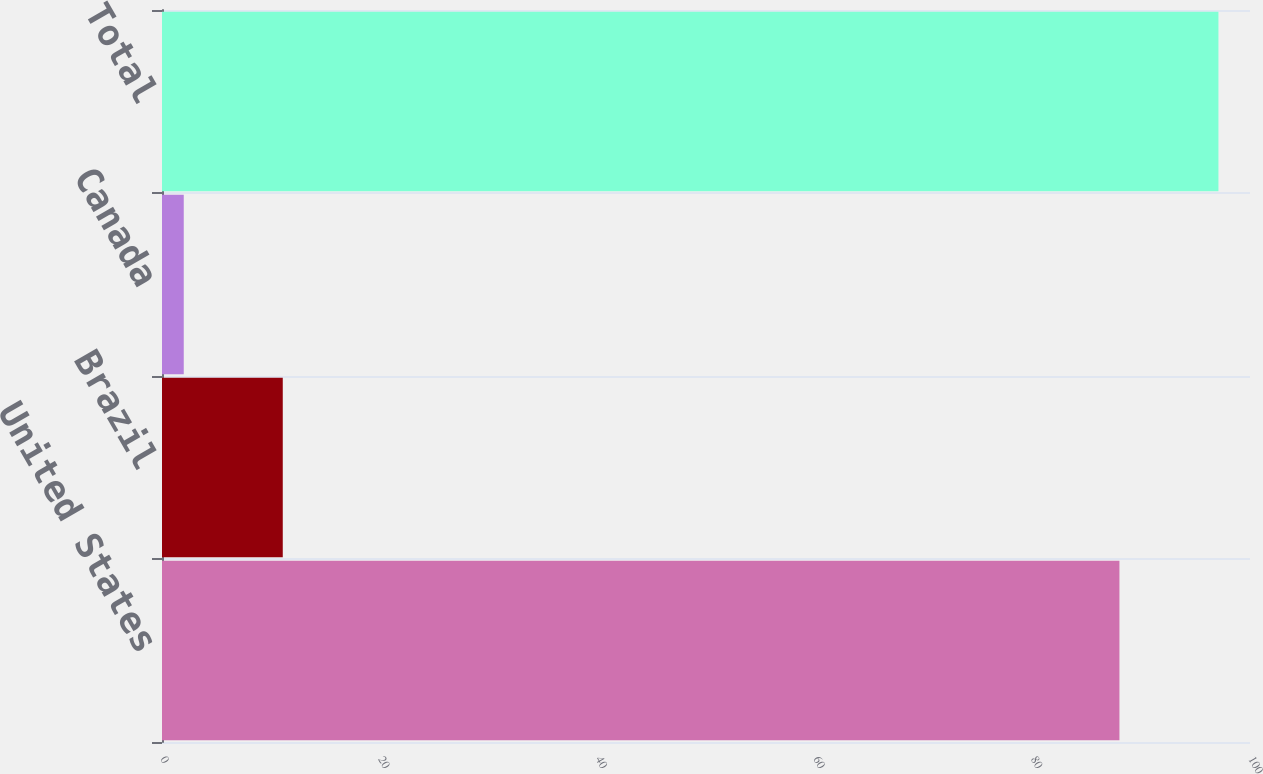Convert chart. <chart><loc_0><loc_0><loc_500><loc_500><bar_chart><fcel>United States<fcel>Brazil<fcel>Canada<fcel>Total<nl><fcel>88<fcel>11.1<fcel>2<fcel>97.1<nl></chart> 